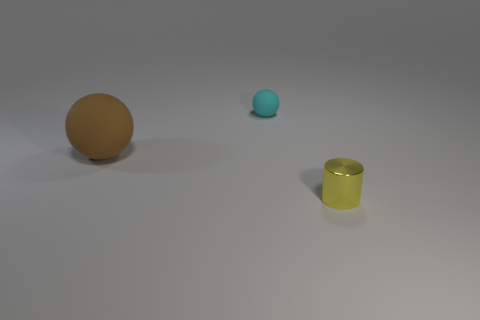Add 1 purple cubes. How many objects exist? 4 Subtract all cyan balls. How many balls are left? 1 Subtract all cylinders. How many objects are left? 2 Subtract 0 blue cubes. How many objects are left? 3 Subtract 1 spheres. How many spheres are left? 1 Subtract all brown cylinders. Subtract all green spheres. How many cylinders are left? 1 Subtract all brown cylinders. How many red spheres are left? 0 Subtract all small brown matte blocks. Subtract all yellow things. How many objects are left? 2 Add 1 big matte objects. How many big matte objects are left? 2 Add 2 yellow rubber spheres. How many yellow rubber spheres exist? 2 